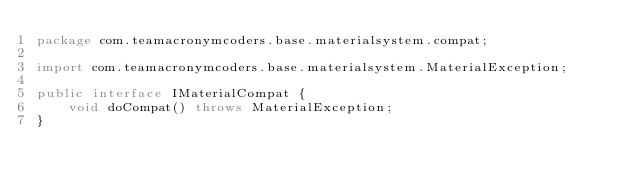<code> <loc_0><loc_0><loc_500><loc_500><_Java_>package com.teamacronymcoders.base.materialsystem.compat;

import com.teamacronymcoders.base.materialsystem.MaterialException;

public interface IMaterialCompat {
    void doCompat() throws MaterialException;
}
</code> 